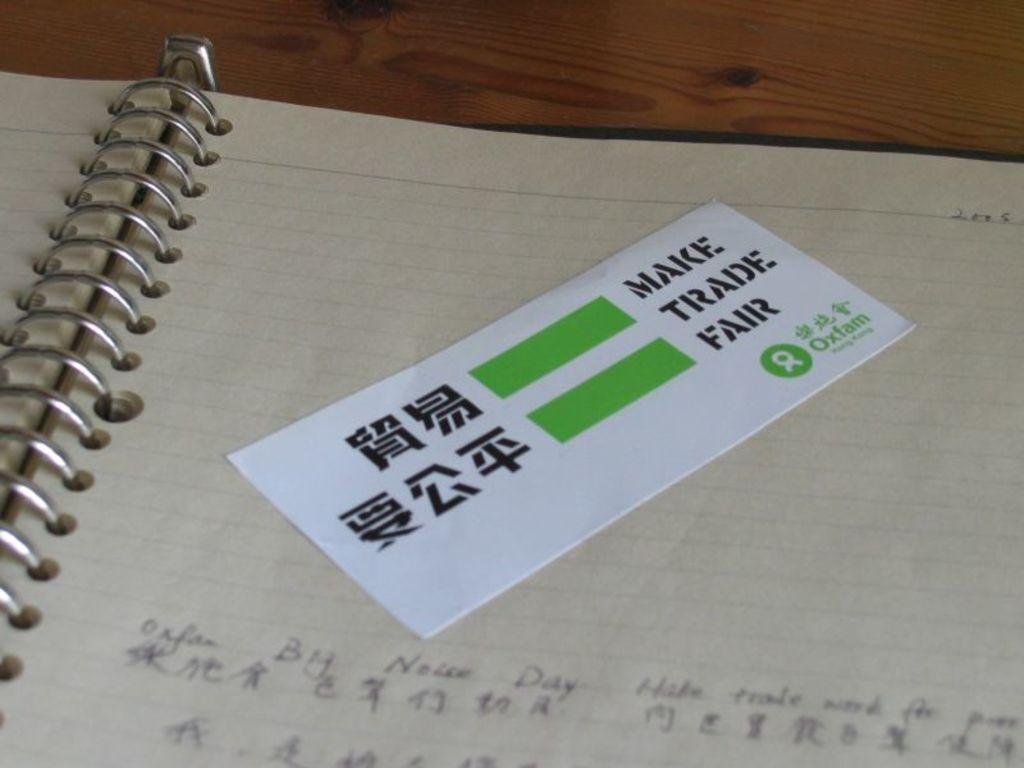<image>
Describe the image concisely. Make trade Fair ticket sits on top of the page of a notebook. 